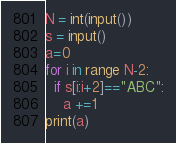<code> <loc_0><loc_0><loc_500><loc_500><_Python_>N = int(input())
s = input()
a=0
for i in range N-2:
  if s[i:i+2]=="ABC":
    a +=1
print(a)</code> 